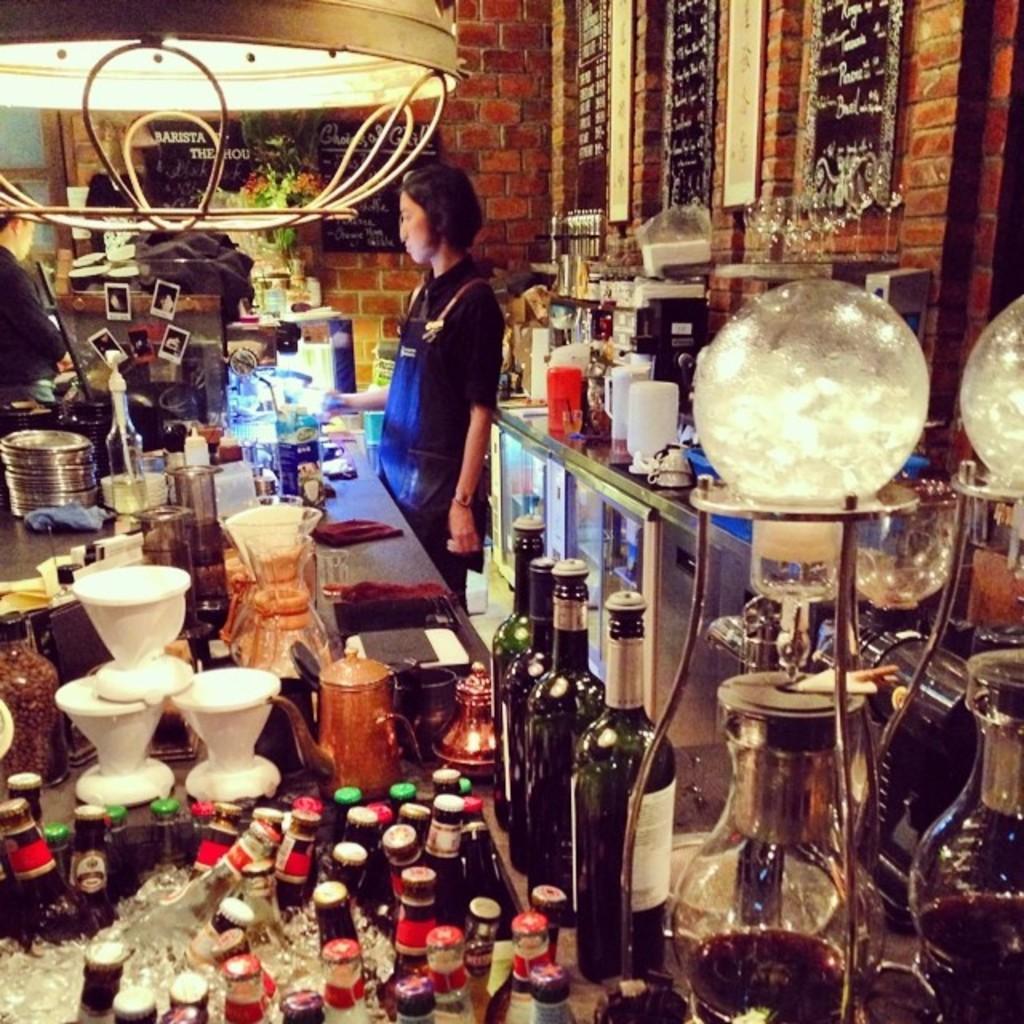How would you summarize this image in a sentence or two? In this image there is a table on that table there are bottles, plates and mug, on either side of the table there are two persons standing, in the background there is a wall at top there is a light on the right side there is a table on that table there are few item and there is a glass item. 